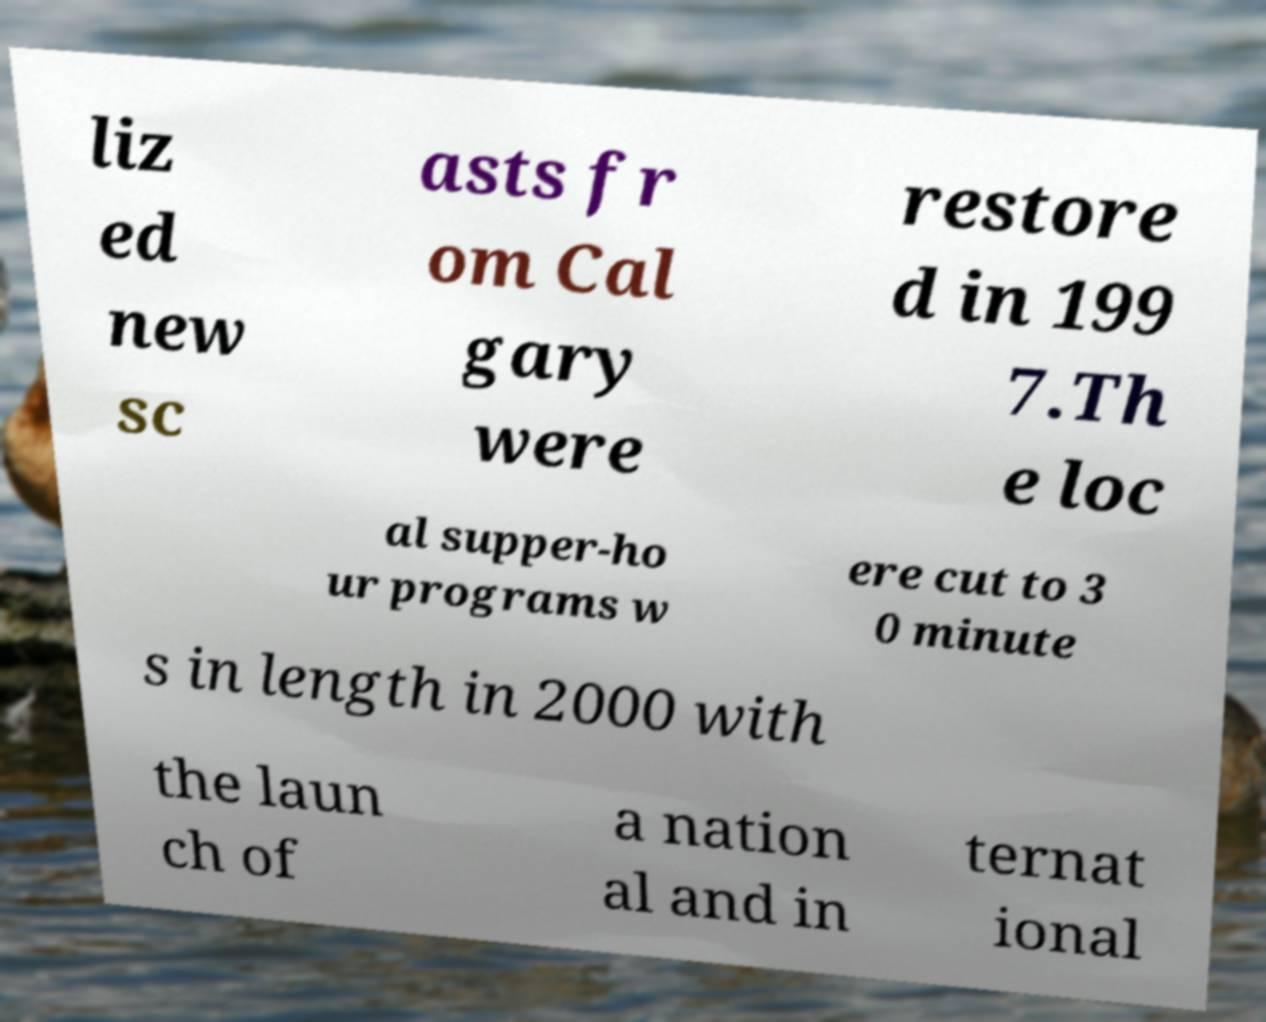Can you accurately transcribe the text from the provided image for me? liz ed new sc asts fr om Cal gary were restore d in 199 7.Th e loc al supper-ho ur programs w ere cut to 3 0 minute s in length in 2000 with the laun ch of a nation al and in ternat ional 